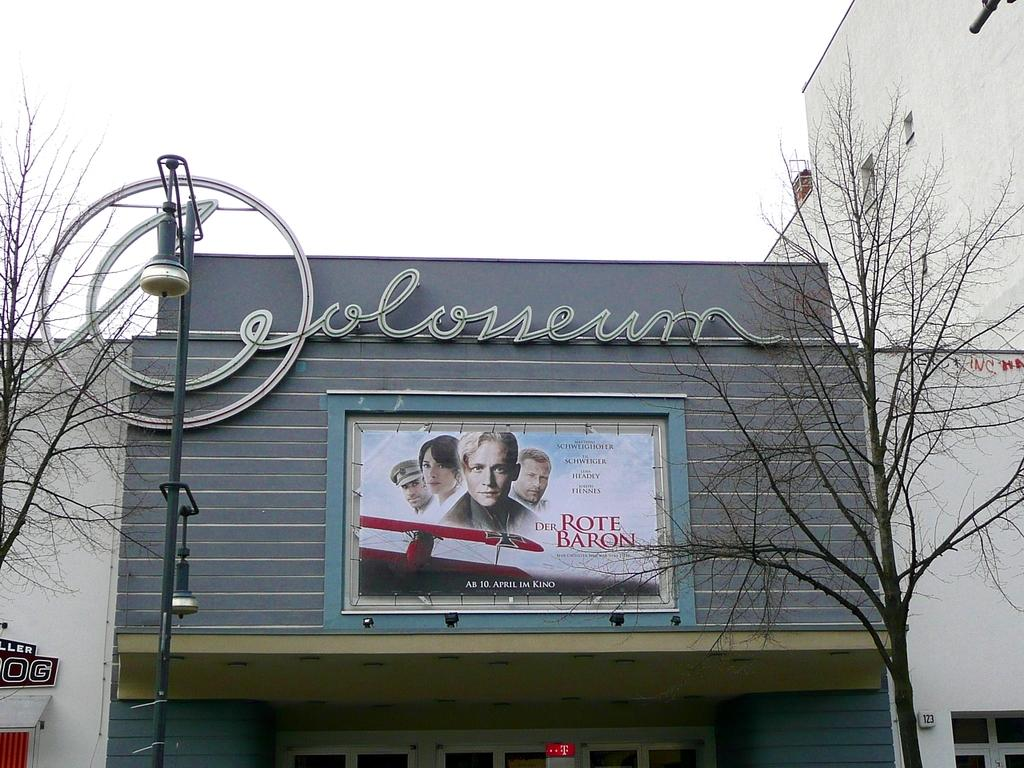<image>
Render a clear and concise summary of the photo. A movie poster picturing four people for the movie titled Der Rote Baron. 